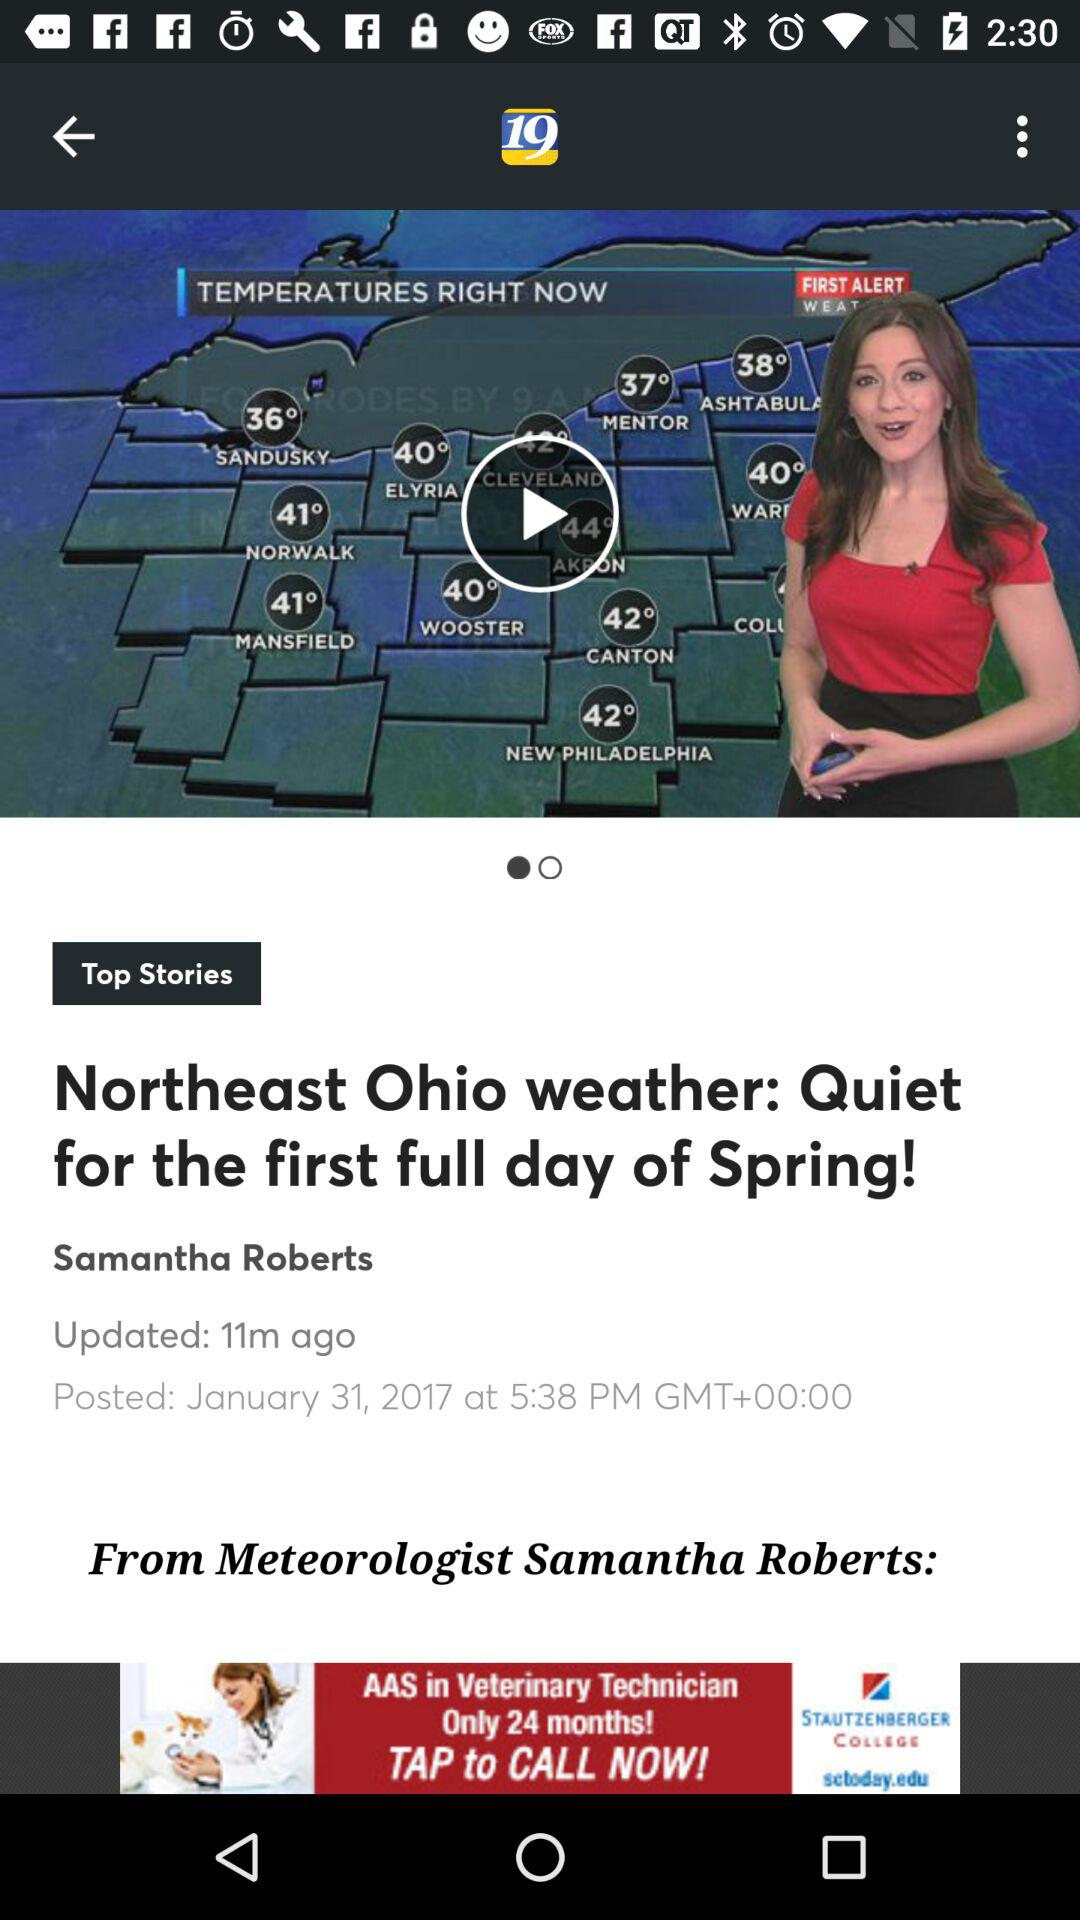How many hours ago was this article posted?
Answer the question using a single word or phrase. 11 